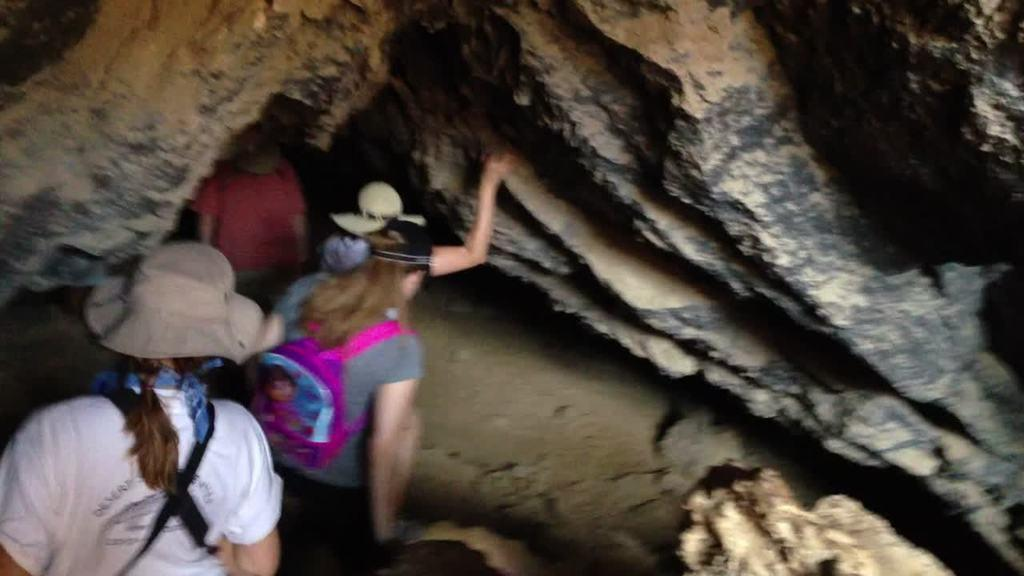Who or what can be seen in the image? There are persons in the image. What are the persons doing in the image? The persons are entering into caves. What type of clam can be seen on the ground in the image? There is no clam present in the image; it features persons entering into caves. What color is the apple on the person's hand in the image? There is no apple present in the image. 